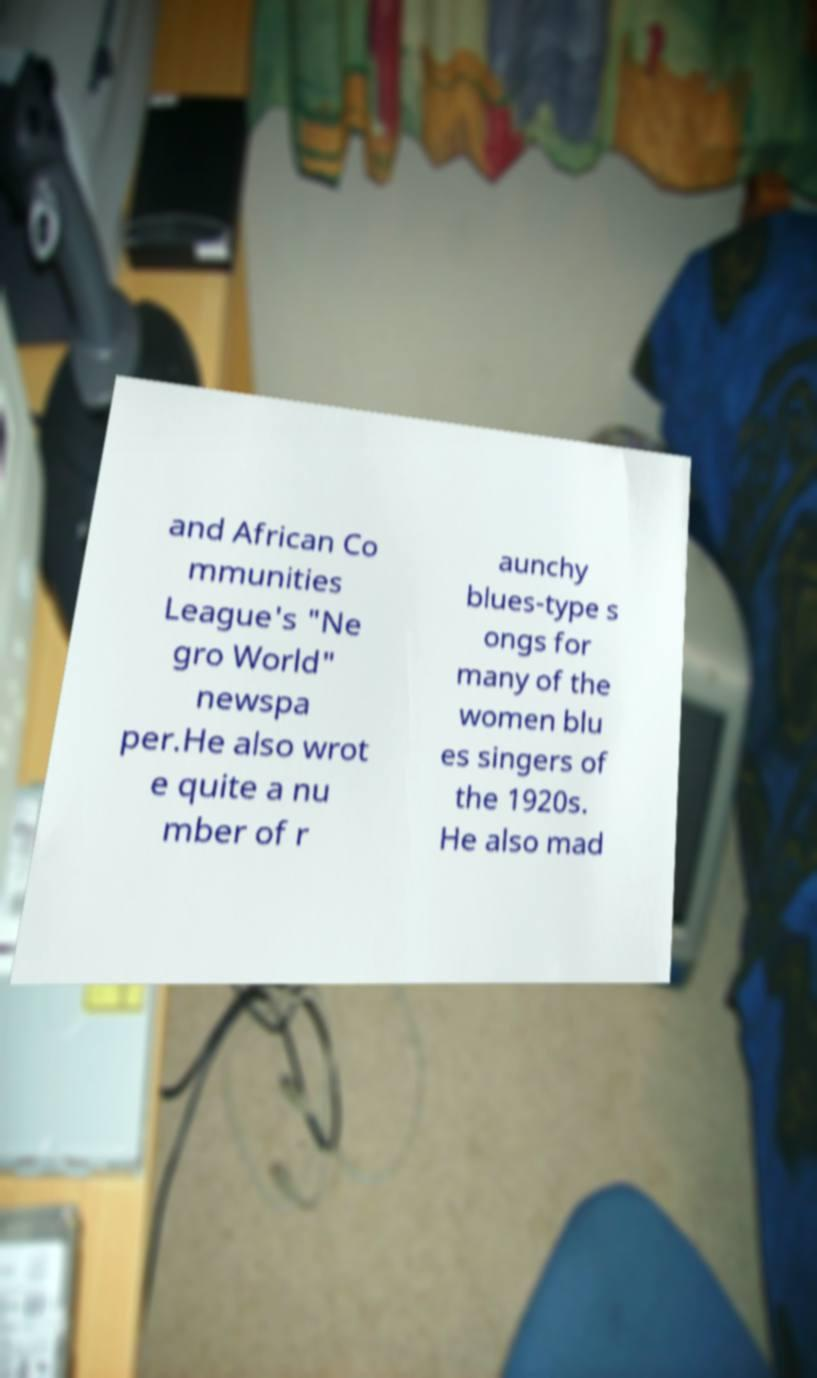What messages or text are displayed in this image? I need them in a readable, typed format. and African Co mmunities League's "Ne gro World" newspa per.He also wrot e quite a nu mber of r aunchy blues-type s ongs for many of the women blu es singers of the 1920s. He also mad 